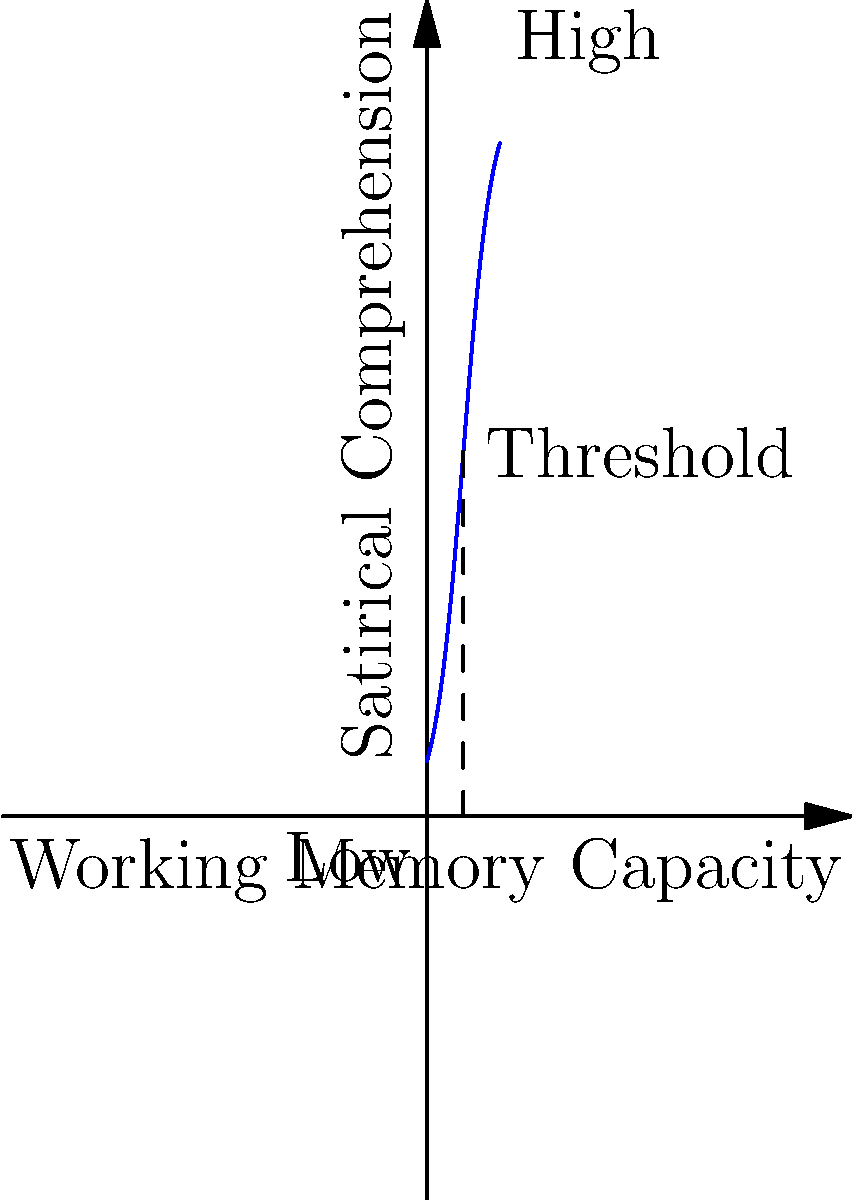Based on the graph depicting the relationship between working memory capacity and satirical comprehension, what cognitive phenomenon best explains the S-shaped curve observed? How might this relate to the processing of complex satirical infographics? 1. Observe the S-shaped curve: The graph shows a nonlinear relationship between working memory capacity and satirical comprehension.

2. Identify key features:
   a. Low working memory capacity corresponds to low satirical comprehension.
   b. There's a steep increase in comprehension at a certain threshold of working memory capacity.
   c. The curve plateaus at high levels of working memory capacity.

3. Cognitive phenomenon explanation:
   The S-shaped curve suggests a cognitive threshold effect, which is consistent with the concept of cognitive load theory.

4. Cognitive load theory application:
   a. When working memory capacity is below the threshold, there are insufficient cognitive resources to process complex satire.
   b. At the threshold, there's a rapid increase in comprehension as cognitive resources become sufficient.
   c. Above the threshold, additional working memory capacity yields diminishing returns in comprehension.

5. Relation to complex satirical infographics:
   a. Infographics often combine visual and textual elements, requiring integration of multiple information sources.
   b. Satire adds another layer of complexity, requiring recognition of incongruity and intended meaning.
   c. Processing these elements simultaneously likely requires a certain threshold of working memory capacity to manage the cognitive load.

6. Implications for individual differences:
   The curve suggests that individuals with working memory capacity below the threshold may struggle significantly with complex satirical infographics, while those above the threshold would show similar levels of comprehension despite varying capacities.
Answer: Cognitive threshold effect, explained by cognitive load theory 